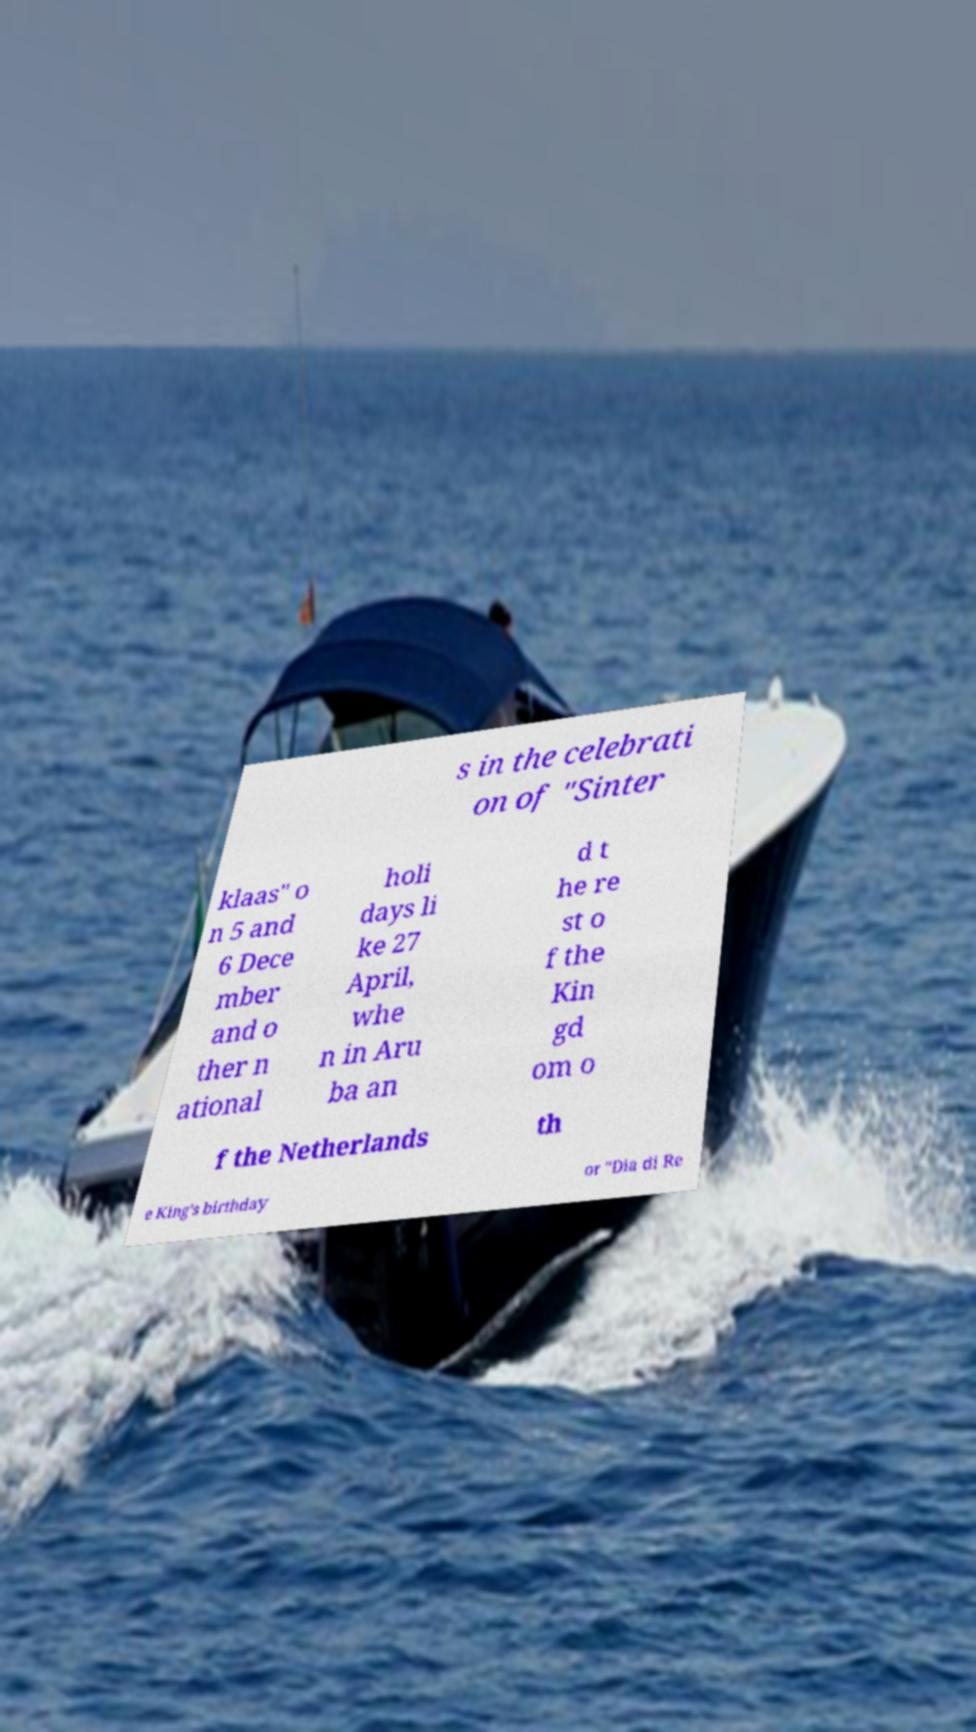Could you extract and type out the text from this image? s in the celebrati on of "Sinter klaas" o n 5 and 6 Dece mber and o ther n ational holi days li ke 27 April, whe n in Aru ba an d t he re st o f the Kin gd om o f the Netherlands th e King's birthday or "Dia di Re 